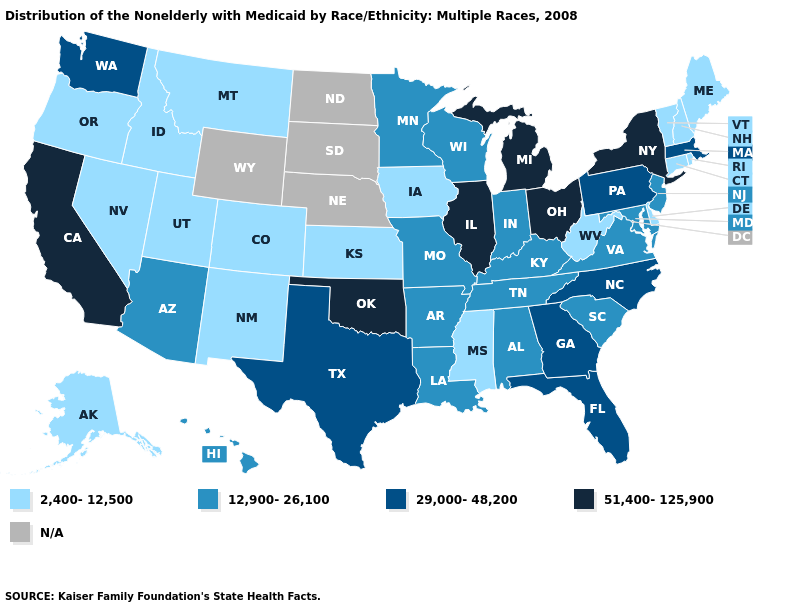What is the value of New Mexico?
Keep it brief. 2,400-12,500. What is the value of Texas?
Give a very brief answer. 29,000-48,200. What is the lowest value in states that border Indiana?
Give a very brief answer. 12,900-26,100. Does Oregon have the highest value in the USA?
Answer briefly. No. Which states have the highest value in the USA?
Quick response, please. California, Illinois, Michigan, New York, Ohio, Oklahoma. Name the states that have a value in the range 2,400-12,500?
Answer briefly. Alaska, Colorado, Connecticut, Delaware, Idaho, Iowa, Kansas, Maine, Mississippi, Montana, Nevada, New Hampshire, New Mexico, Oregon, Rhode Island, Utah, Vermont, West Virginia. Does Texas have the highest value in the USA?
Be succinct. No. Name the states that have a value in the range 2,400-12,500?
Quick response, please. Alaska, Colorado, Connecticut, Delaware, Idaho, Iowa, Kansas, Maine, Mississippi, Montana, Nevada, New Hampshire, New Mexico, Oregon, Rhode Island, Utah, Vermont, West Virginia. What is the value of North Dakota?
Short answer required. N/A. Does Utah have the highest value in the USA?
Write a very short answer. No. What is the value of Alaska?
Give a very brief answer. 2,400-12,500. What is the value of Alaska?
Concise answer only. 2,400-12,500. Does Indiana have the lowest value in the MidWest?
Keep it brief. No. What is the value of Kansas?
Keep it brief. 2,400-12,500. 